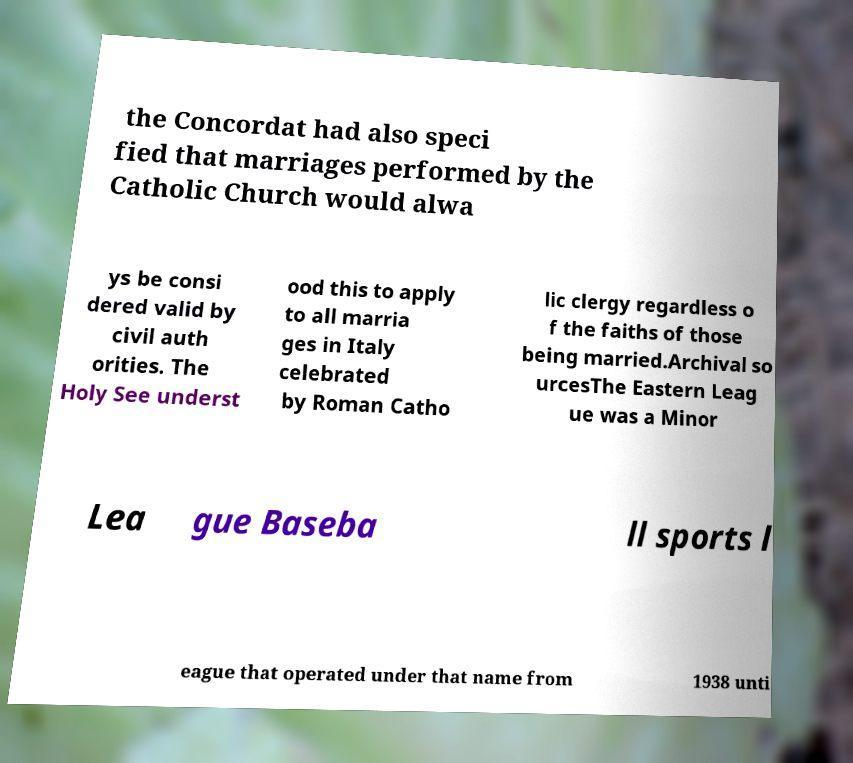Please read and relay the text visible in this image. What does it say? the Concordat had also speci fied that marriages performed by the Catholic Church would alwa ys be consi dered valid by civil auth orities. The Holy See underst ood this to apply to all marria ges in Italy celebrated by Roman Catho lic clergy regardless o f the faiths of those being married.Archival so urcesThe Eastern Leag ue was a Minor Lea gue Baseba ll sports l eague that operated under that name from 1938 unti 